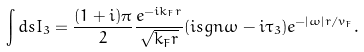Convert formula to latex. <formula><loc_0><loc_0><loc_500><loc_500>\int d s I _ { 3 } = \frac { ( 1 + i ) \pi } { 2 } \frac { e ^ { - i k _ { F } r } } { \sqrt { k _ { F } r } } ( i s g n \omega - i \tau _ { 3 } ) e ^ { - | \omega | r / v _ { F } } .</formula> 